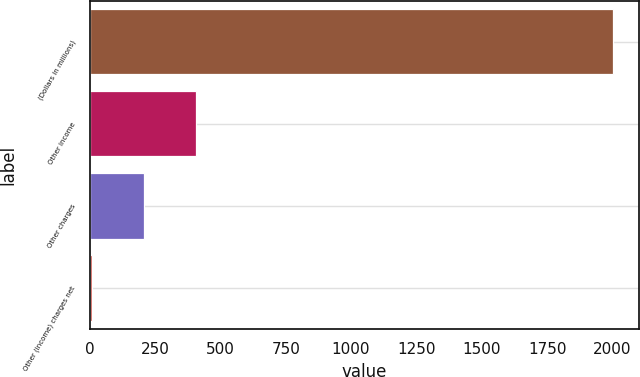Convert chart. <chart><loc_0><loc_0><loc_500><loc_500><bar_chart><fcel>(Dollars in millions)<fcel>Other income<fcel>Other charges<fcel>Other (income) charges net<nl><fcel>2003<fcel>408.6<fcel>209.3<fcel>10<nl></chart> 